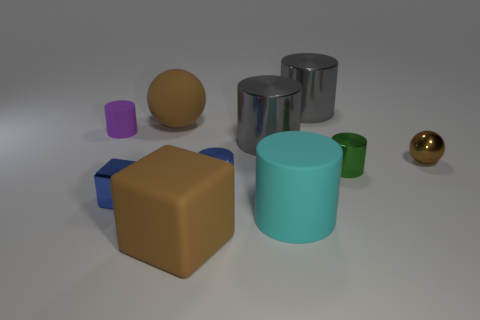How would you describe the lighting and shadows in this scene? The lighting in the scene appears to be diffused, with soft shadows trailing to the right of the objects, indicating a light source to the left of the scene. This setup provides a gentle illumination which enhances the objects' three-dimensional appearance without causing harsh highlights. 